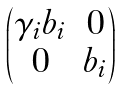Convert formula to latex. <formula><loc_0><loc_0><loc_500><loc_500>\begin{pmatrix} \gamma _ { i } b _ { i } & 0 \\ 0 & b _ { i } \end{pmatrix}</formula> 